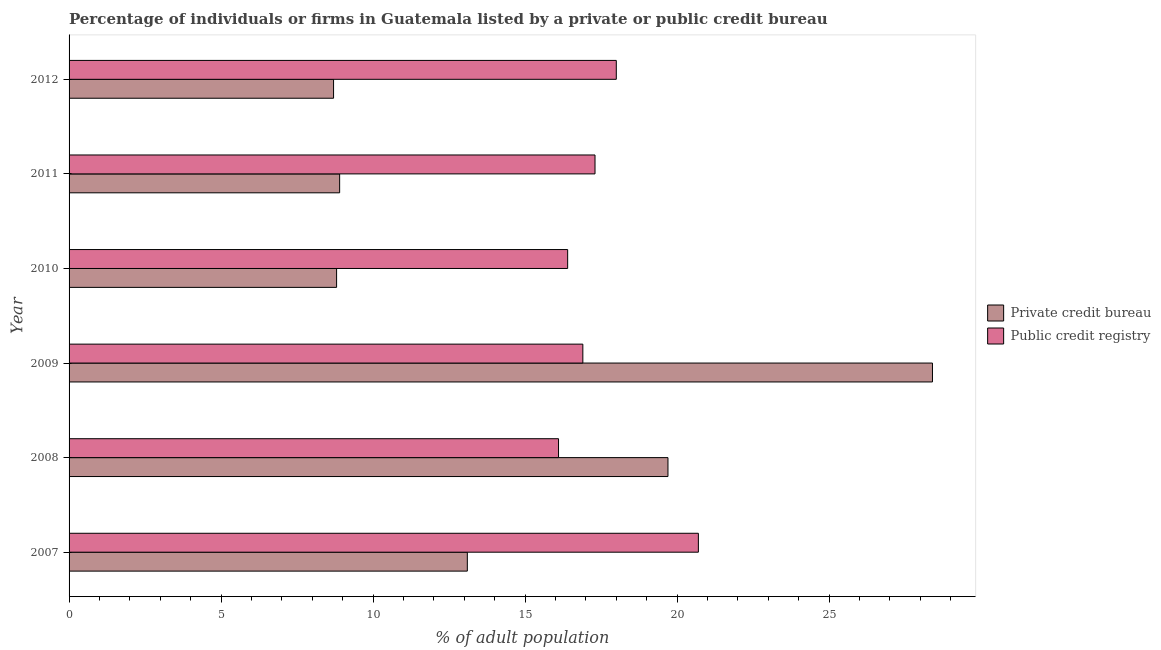How many groups of bars are there?
Ensure brevity in your answer.  6. What is the label of the 2nd group of bars from the top?
Provide a succinct answer. 2011. In how many cases, is the number of bars for a given year not equal to the number of legend labels?
Offer a terse response. 0. What is the percentage of firms listed by public credit bureau in 2009?
Ensure brevity in your answer.  16.9. Across all years, what is the maximum percentage of firms listed by public credit bureau?
Offer a terse response. 20.7. Across all years, what is the minimum percentage of firms listed by private credit bureau?
Your response must be concise. 8.7. In which year was the percentage of firms listed by public credit bureau minimum?
Your answer should be compact. 2008. What is the total percentage of firms listed by private credit bureau in the graph?
Provide a short and direct response. 87.6. What is the difference between the percentage of firms listed by private credit bureau in 2009 and that in 2010?
Your answer should be very brief. 19.6. What is the difference between the percentage of firms listed by private credit bureau in 2009 and the percentage of firms listed by public credit bureau in 2012?
Keep it short and to the point. 10.4. What is the average percentage of firms listed by private credit bureau per year?
Ensure brevity in your answer.  14.6. In how many years, is the percentage of firms listed by private credit bureau greater than 12 %?
Offer a very short reply. 3. What is the ratio of the percentage of firms listed by public credit bureau in 2008 to that in 2011?
Give a very brief answer. 0.93. Is the percentage of firms listed by public credit bureau in 2007 less than that in 2011?
Make the answer very short. No. What is the difference between the highest and the second highest percentage of firms listed by public credit bureau?
Keep it short and to the point. 2.7. What is the difference between the highest and the lowest percentage of firms listed by private credit bureau?
Offer a terse response. 19.7. Is the sum of the percentage of firms listed by public credit bureau in 2009 and 2012 greater than the maximum percentage of firms listed by private credit bureau across all years?
Give a very brief answer. Yes. What does the 1st bar from the top in 2011 represents?
Make the answer very short. Public credit registry. What does the 2nd bar from the bottom in 2008 represents?
Make the answer very short. Public credit registry. How many bars are there?
Offer a very short reply. 12. What is the difference between two consecutive major ticks on the X-axis?
Your answer should be very brief. 5. Does the graph contain any zero values?
Give a very brief answer. No. Where does the legend appear in the graph?
Your response must be concise. Center right. How are the legend labels stacked?
Ensure brevity in your answer.  Vertical. What is the title of the graph?
Your answer should be very brief. Percentage of individuals or firms in Guatemala listed by a private or public credit bureau. What is the label or title of the X-axis?
Your answer should be very brief. % of adult population. What is the % of adult population in Public credit registry in 2007?
Give a very brief answer. 20.7. What is the % of adult population of Private credit bureau in 2008?
Your answer should be compact. 19.7. What is the % of adult population in Private credit bureau in 2009?
Ensure brevity in your answer.  28.4. What is the % of adult population of Public credit registry in 2009?
Ensure brevity in your answer.  16.9. What is the % of adult population in Private credit bureau in 2010?
Provide a succinct answer. 8.8. What is the % of adult population in Public credit registry in 2010?
Give a very brief answer. 16.4. What is the % of adult population in Public credit registry in 2011?
Your answer should be very brief. 17.3. What is the % of adult population of Private credit bureau in 2012?
Your answer should be compact. 8.7. What is the % of adult population in Public credit registry in 2012?
Make the answer very short. 18. Across all years, what is the maximum % of adult population of Private credit bureau?
Provide a succinct answer. 28.4. Across all years, what is the maximum % of adult population in Public credit registry?
Keep it short and to the point. 20.7. Across all years, what is the minimum % of adult population of Private credit bureau?
Your response must be concise. 8.7. Across all years, what is the minimum % of adult population in Public credit registry?
Ensure brevity in your answer.  16.1. What is the total % of adult population of Private credit bureau in the graph?
Make the answer very short. 87.6. What is the total % of adult population of Public credit registry in the graph?
Give a very brief answer. 105.4. What is the difference between the % of adult population of Private credit bureau in 2007 and that in 2008?
Provide a short and direct response. -6.6. What is the difference between the % of adult population of Public credit registry in 2007 and that in 2008?
Your answer should be compact. 4.6. What is the difference between the % of adult population in Private credit bureau in 2007 and that in 2009?
Your answer should be very brief. -15.3. What is the difference between the % of adult population of Private credit bureau in 2007 and that in 2010?
Your answer should be compact. 4.3. What is the difference between the % of adult population of Private credit bureau in 2007 and that in 2011?
Give a very brief answer. 4.2. What is the difference between the % of adult population in Private credit bureau in 2007 and that in 2012?
Ensure brevity in your answer.  4.4. What is the difference between the % of adult population of Public credit registry in 2007 and that in 2012?
Give a very brief answer. 2.7. What is the difference between the % of adult population of Private credit bureau in 2008 and that in 2009?
Your answer should be very brief. -8.7. What is the difference between the % of adult population of Public credit registry in 2008 and that in 2009?
Keep it short and to the point. -0.8. What is the difference between the % of adult population in Private credit bureau in 2008 and that in 2011?
Offer a very short reply. 10.8. What is the difference between the % of adult population in Private credit bureau in 2009 and that in 2010?
Offer a very short reply. 19.6. What is the difference between the % of adult population in Private credit bureau in 2010 and that in 2011?
Offer a terse response. -0.1. What is the difference between the % of adult population in Public credit registry in 2010 and that in 2011?
Offer a terse response. -0.9. What is the difference between the % of adult population in Private credit bureau in 2010 and that in 2012?
Offer a very short reply. 0.1. What is the difference between the % of adult population of Public credit registry in 2010 and that in 2012?
Offer a terse response. -1.6. What is the difference between the % of adult population of Public credit registry in 2011 and that in 2012?
Your response must be concise. -0.7. What is the difference between the % of adult population of Private credit bureau in 2007 and the % of adult population of Public credit registry in 2008?
Provide a succinct answer. -3. What is the difference between the % of adult population of Private credit bureau in 2007 and the % of adult population of Public credit registry in 2009?
Give a very brief answer. -3.8. What is the difference between the % of adult population in Private credit bureau in 2008 and the % of adult population in Public credit registry in 2009?
Your answer should be compact. 2.8. What is the difference between the % of adult population of Private credit bureau in 2008 and the % of adult population of Public credit registry in 2012?
Offer a terse response. 1.7. What is the difference between the % of adult population in Private credit bureau in 2009 and the % of adult population in Public credit registry in 2010?
Your response must be concise. 12. What is the difference between the % of adult population in Private credit bureau in 2010 and the % of adult population in Public credit registry in 2011?
Offer a terse response. -8.5. What is the difference between the % of adult population in Private credit bureau in 2010 and the % of adult population in Public credit registry in 2012?
Ensure brevity in your answer.  -9.2. What is the difference between the % of adult population in Private credit bureau in 2011 and the % of adult population in Public credit registry in 2012?
Make the answer very short. -9.1. What is the average % of adult population in Private credit bureau per year?
Ensure brevity in your answer.  14.6. What is the average % of adult population in Public credit registry per year?
Your answer should be very brief. 17.57. In the year 2007, what is the difference between the % of adult population of Private credit bureau and % of adult population of Public credit registry?
Your answer should be compact. -7.6. In the year 2009, what is the difference between the % of adult population of Private credit bureau and % of adult population of Public credit registry?
Ensure brevity in your answer.  11.5. In the year 2010, what is the difference between the % of adult population in Private credit bureau and % of adult population in Public credit registry?
Your answer should be compact. -7.6. In the year 2011, what is the difference between the % of adult population in Private credit bureau and % of adult population in Public credit registry?
Your response must be concise. -8.4. What is the ratio of the % of adult population in Private credit bureau in 2007 to that in 2008?
Offer a very short reply. 0.67. What is the ratio of the % of adult population in Private credit bureau in 2007 to that in 2009?
Offer a very short reply. 0.46. What is the ratio of the % of adult population in Public credit registry in 2007 to that in 2009?
Your answer should be compact. 1.22. What is the ratio of the % of adult population of Private credit bureau in 2007 to that in 2010?
Provide a succinct answer. 1.49. What is the ratio of the % of adult population of Public credit registry in 2007 to that in 2010?
Offer a terse response. 1.26. What is the ratio of the % of adult population in Private credit bureau in 2007 to that in 2011?
Give a very brief answer. 1.47. What is the ratio of the % of adult population of Public credit registry in 2007 to that in 2011?
Give a very brief answer. 1.2. What is the ratio of the % of adult population of Private credit bureau in 2007 to that in 2012?
Offer a very short reply. 1.51. What is the ratio of the % of adult population of Public credit registry in 2007 to that in 2012?
Provide a succinct answer. 1.15. What is the ratio of the % of adult population in Private credit bureau in 2008 to that in 2009?
Ensure brevity in your answer.  0.69. What is the ratio of the % of adult population in Public credit registry in 2008 to that in 2009?
Ensure brevity in your answer.  0.95. What is the ratio of the % of adult population of Private credit bureau in 2008 to that in 2010?
Your answer should be very brief. 2.24. What is the ratio of the % of adult population of Public credit registry in 2008 to that in 2010?
Make the answer very short. 0.98. What is the ratio of the % of adult population of Private credit bureau in 2008 to that in 2011?
Provide a succinct answer. 2.21. What is the ratio of the % of adult population in Public credit registry in 2008 to that in 2011?
Make the answer very short. 0.93. What is the ratio of the % of adult population of Private credit bureau in 2008 to that in 2012?
Offer a terse response. 2.26. What is the ratio of the % of adult population of Public credit registry in 2008 to that in 2012?
Offer a terse response. 0.89. What is the ratio of the % of adult population in Private credit bureau in 2009 to that in 2010?
Provide a succinct answer. 3.23. What is the ratio of the % of adult population of Public credit registry in 2009 to that in 2010?
Give a very brief answer. 1.03. What is the ratio of the % of adult population of Private credit bureau in 2009 to that in 2011?
Ensure brevity in your answer.  3.19. What is the ratio of the % of adult population in Public credit registry in 2009 to that in 2011?
Your answer should be compact. 0.98. What is the ratio of the % of adult population of Private credit bureau in 2009 to that in 2012?
Make the answer very short. 3.26. What is the ratio of the % of adult population of Public credit registry in 2009 to that in 2012?
Provide a short and direct response. 0.94. What is the ratio of the % of adult population of Private credit bureau in 2010 to that in 2011?
Your answer should be very brief. 0.99. What is the ratio of the % of adult population of Public credit registry in 2010 to that in 2011?
Provide a succinct answer. 0.95. What is the ratio of the % of adult population of Private credit bureau in 2010 to that in 2012?
Give a very brief answer. 1.01. What is the ratio of the % of adult population in Public credit registry in 2010 to that in 2012?
Give a very brief answer. 0.91. What is the ratio of the % of adult population of Private credit bureau in 2011 to that in 2012?
Your response must be concise. 1.02. What is the ratio of the % of adult population in Public credit registry in 2011 to that in 2012?
Keep it short and to the point. 0.96. What is the difference between the highest and the second highest % of adult population of Private credit bureau?
Your answer should be very brief. 8.7. What is the difference between the highest and the lowest % of adult population in Public credit registry?
Your answer should be very brief. 4.6. 